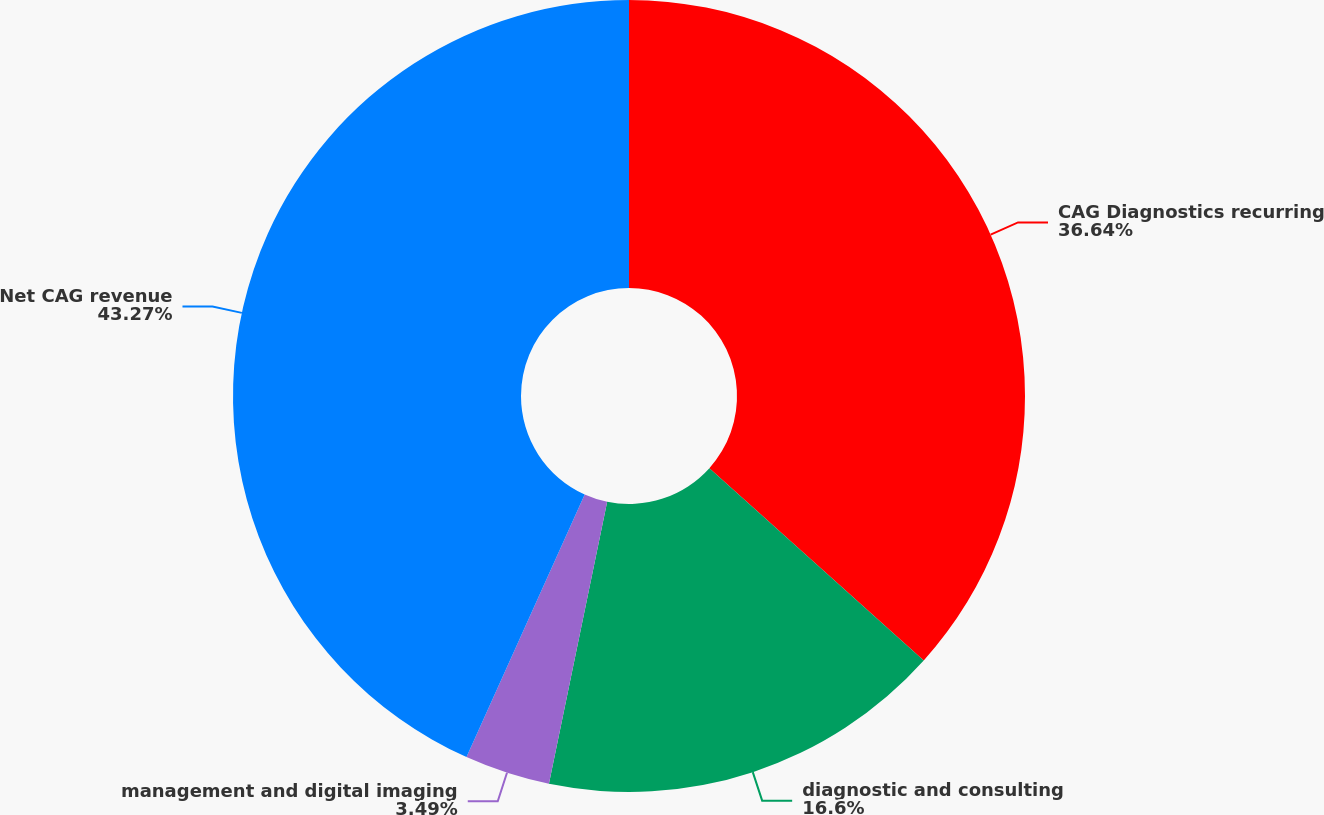<chart> <loc_0><loc_0><loc_500><loc_500><pie_chart><fcel>CAG Diagnostics recurring<fcel>diagnostic and consulting<fcel>management and digital imaging<fcel>Net CAG revenue<nl><fcel>36.64%<fcel>16.6%<fcel>3.49%<fcel>43.27%<nl></chart> 